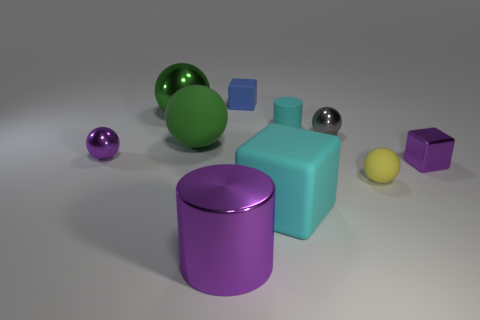What number of spheres are large green things or tiny cyan rubber things?
Offer a terse response. 2. What is the color of the large thing in front of the big cyan rubber cube?
Your answer should be very brief. Purple. There is a rubber object that is the same color as the big shiny ball; what shape is it?
Make the answer very short. Sphere. How many cubes have the same size as the metal cylinder?
Ensure brevity in your answer.  1. There is a purple object to the right of the small cyan rubber object; is its shape the same as the purple shiny object that is behind the small metal cube?
Offer a very short reply. No. What material is the cylinder behind the tiny block that is in front of the block behind the green matte thing made of?
Provide a succinct answer. Rubber. The yellow thing that is the same size as the gray thing is what shape?
Ensure brevity in your answer.  Sphere. Are there any tiny matte objects of the same color as the tiny rubber block?
Your answer should be very brief. No. What is the size of the gray thing?
Provide a short and direct response. Small. Do the small cyan cylinder and the purple cube have the same material?
Provide a succinct answer. No. 